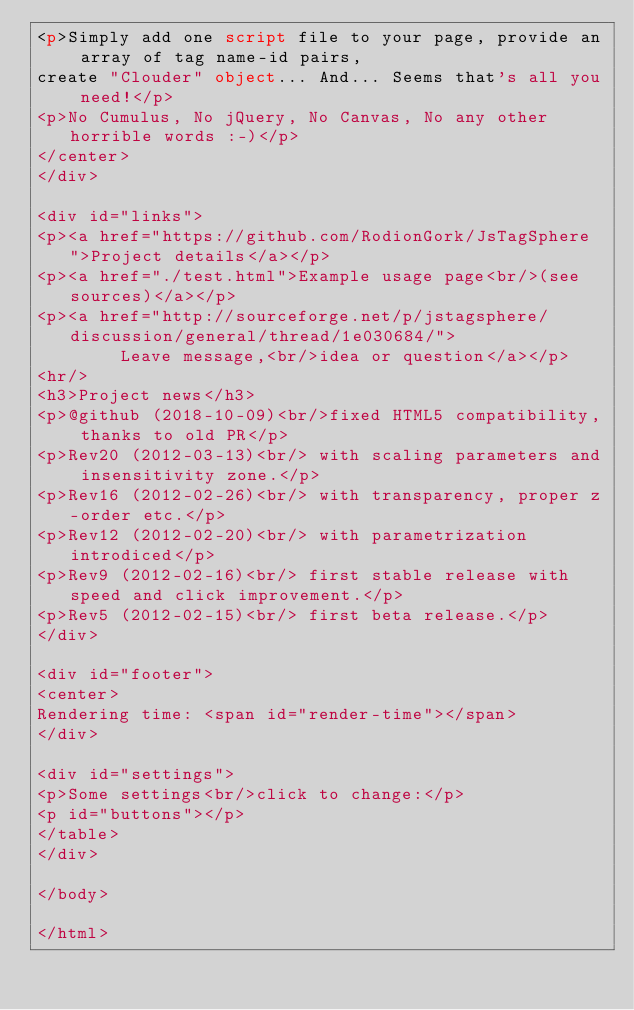Convert code to text. <code><loc_0><loc_0><loc_500><loc_500><_HTML_><p>Simply add one script file to your page, provide an array of tag name-id pairs,
create "Clouder" object... And... Seems that's all you need!</p>
<p>No Cumulus, No jQuery, No Canvas, No any other horrible words :-)</p>
</center>
</div>

<div id="links">
<p><a href="https://github.com/RodionGork/JsTagSphere">Project details</a></p>
<p><a href="./test.html">Example usage page<br/>(see sources)</a></p>
<p><a href="http://sourceforge.net/p/jstagsphere/discussion/general/thread/1e030684/">
        Leave message,<br/>idea or question</a></p>
<hr/>
<h3>Project news</h3>
<p>@github (2018-10-09)<br/>fixed HTML5 compatibility, thanks to old PR</p>
<p>Rev20 (2012-03-13)<br/> with scaling parameters and insensitivity zone.</p>
<p>Rev16 (2012-02-26)<br/> with transparency, proper z-order etc.</p>
<p>Rev12 (2012-02-20)<br/> with parametrization introdiced</p>
<p>Rev9 (2012-02-16)<br/> first stable release with speed and click improvement.</p>
<p>Rev5 (2012-02-15)<br/> first beta release.</p>
</div>

<div id="footer">
<center>
Rendering time: <span id="render-time"></span>
</div>

<div id="settings">
<p>Some settings<br/>click to change:</p>
<p id="buttons"></p>
</table>
</div>

</body>

</html>

</code> 